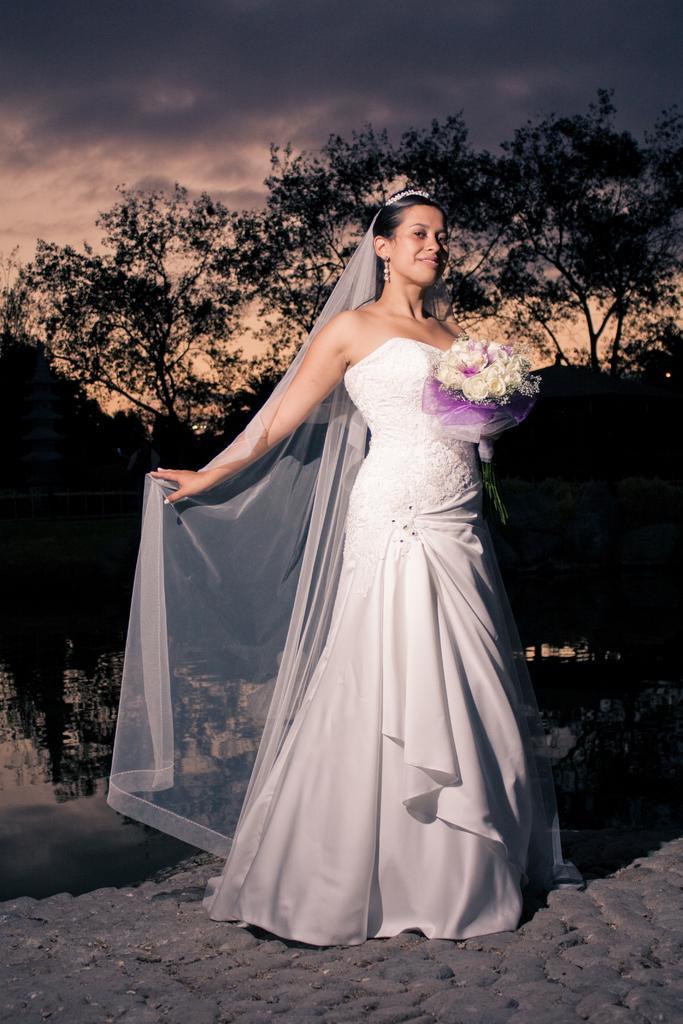Please provide a concise description of this image. In this image there is a woman wearing white color frock and holding white color flower bouquet. There is a road. There are trees in the background. The sky is dark. 